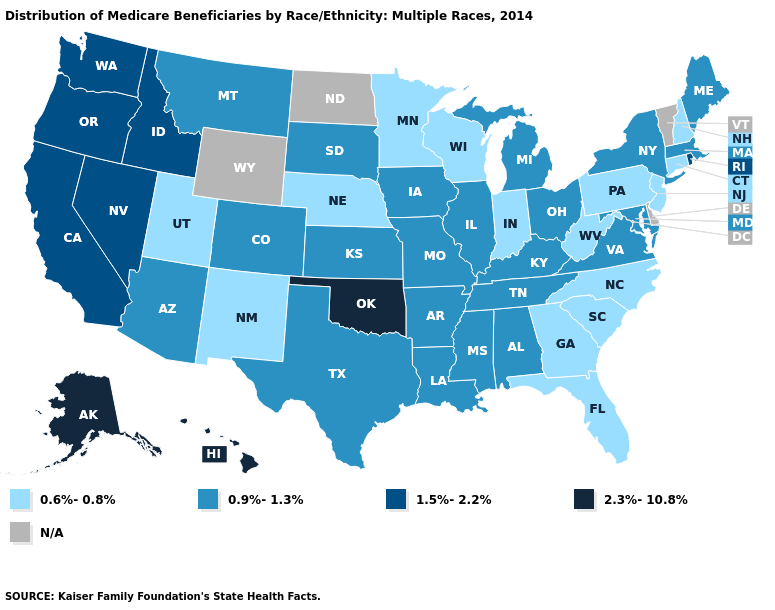What is the lowest value in states that border New Mexico?
Answer briefly. 0.6%-0.8%. What is the lowest value in states that border Minnesota?
Concise answer only. 0.6%-0.8%. Among the states that border Kansas , does Colorado have the lowest value?
Concise answer only. No. What is the value of Pennsylvania?
Be succinct. 0.6%-0.8%. What is the lowest value in the USA?
Be succinct. 0.6%-0.8%. How many symbols are there in the legend?
Write a very short answer. 5. What is the value of Pennsylvania?
Short answer required. 0.6%-0.8%. What is the highest value in states that border Kentucky?
Be succinct. 0.9%-1.3%. How many symbols are there in the legend?
Give a very brief answer. 5. Among the states that border Kansas , does Oklahoma have the highest value?
Quick response, please. Yes. Among the states that border Illinois , which have the lowest value?
Short answer required. Indiana, Wisconsin. What is the value of Idaho?
Answer briefly. 1.5%-2.2%. Does Indiana have the lowest value in the MidWest?
Write a very short answer. Yes. Name the states that have a value in the range 0.9%-1.3%?
Short answer required. Alabama, Arizona, Arkansas, Colorado, Illinois, Iowa, Kansas, Kentucky, Louisiana, Maine, Maryland, Massachusetts, Michigan, Mississippi, Missouri, Montana, New York, Ohio, South Dakota, Tennessee, Texas, Virginia. 